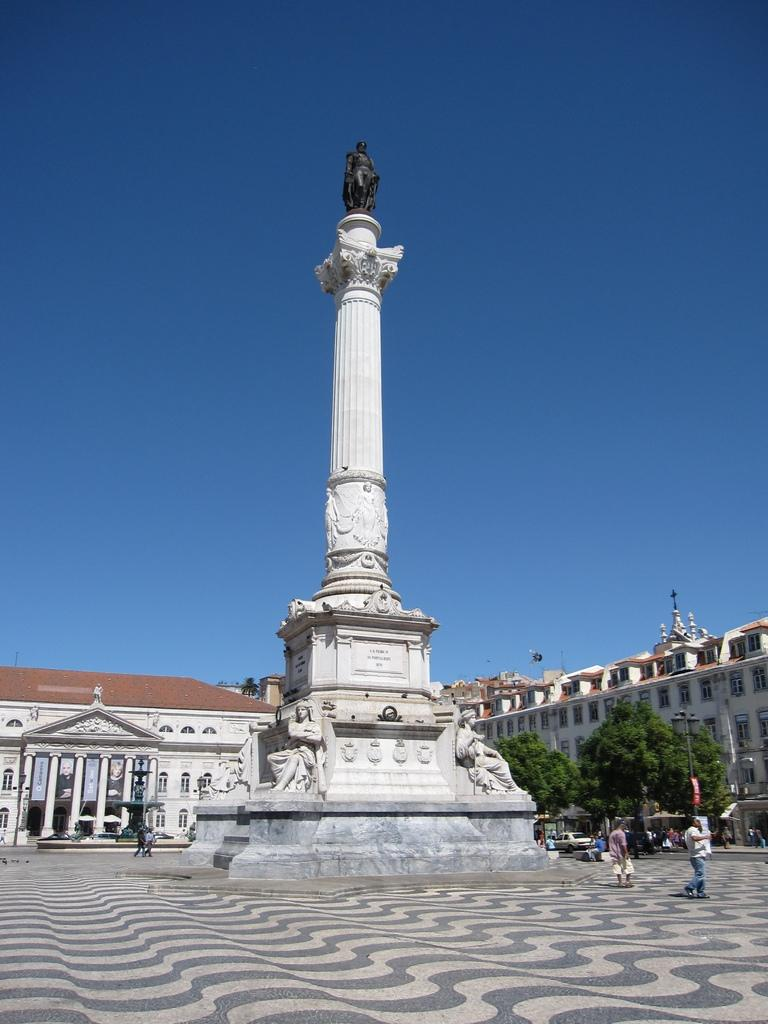What type of structures can be seen in the image? There are buildings in the image. What feature can be found on the buildings and possibly other objects? There are windows in the image. What type of vegetation is present in the image? There are trees in the image. What type of transportation can be seen in the image? There are vehicles in the image. Are there any living beings visible in the image? Yes, there are people in the image. What is visible at the top of the image? The sky is visible at the top of the image. What type of cheese is hanging from the trees in the image? There is no cheese present in the image; it features buildings, windows, trees, vehicles, people, and a visible sky. In which direction are the people walking in the image? The provided facts do not mention any specific direction of walking for the people in the image. 